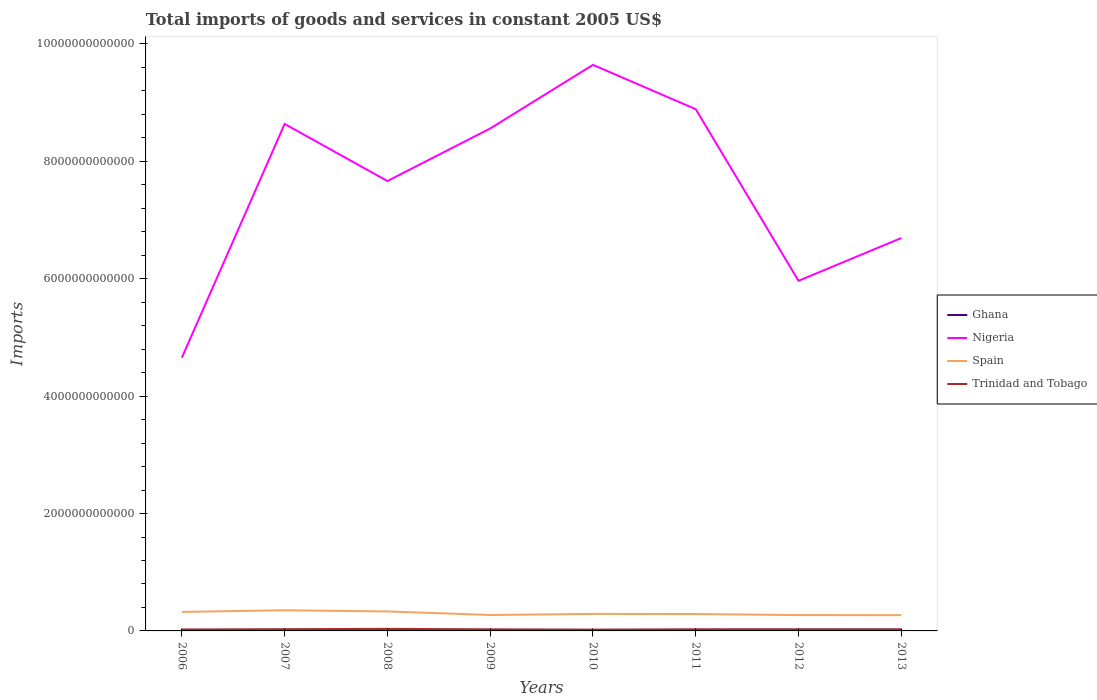How many different coloured lines are there?
Give a very brief answer. 4. Does the line corresponding to Spain intersect with the line corresponding to Ghana?
Keep it short and to the point. No. Is the number of lines equal to the number of legend labels?
Provide a succinct answer. Yes. Across all years, what is the maximum total imports of goods and services in Nigeria?
Give a very brief answer. 4.66e+12. What is the total total imports of goods and services in Spain in the graph?
Provide a short and direct response. -1.64e+1. What is the difference between the highest and the second highest total imports of goods and services in Spain?
Keep it short and to the point. 8.28e+1. What is the difference between the highest and the lowest total imports of goods and services in Trinidad and Tobago?
Offer a terse response. 2. Is the total imports of goods and services in Ghana strictly greater than the total imports of goods and services in Trinidad and Tobago over the years?
Make the answer very short. Yes. How many lines are there?
Ensure brevity in your answer.  4. How many years are there in the graph?
Provide a succinct answer. 8. What is the difference between two consecutive major ticks on the Y-axis?
Provide a short and direct response. 2.00e+12. How many legend labels are there?
Ensure brevity in your answer.  4. How are the legend labels stacked?
Keep it short and to the point. Vertical. What is the title of the graph?
Your answer should be compact. Total imports of goods and services in constant 2005 US$. What is the label or title of the X-axis?
Your answer should be very brief. Years. What is the label or title of the Y-axis?
Offer a very short reply. Imports. What is the Imports of Ghana in 2006?
Give a very brief answer. 7.62e+09. What is the Imports of Nigeria in 2006?
Keep it short and to the point. 4.66e+12. What is the Imports of Spain in 2006?
Provide a succinct answer. 3.24e+11. What is the Imports of Trinidad and Tobago in 2006?
Make the answer very short. 2.49e+1. What is the Imports in Ghana in 2007?
Make the answer very short. 9.27e+09. What is the Imports of Nigeria in 2007?
Provide a succinct answer. 8.64e+12. What is the Imports of Spain in 2007?
Provide a short and direct response. 3.52e+11. What is the Imports in Trinidad and Tobago in 2007?
Your answer should be compact. 2.99e+1. What is the Imports of Ghana in 2008?
Your answer should be very brief. 1.16e+1. What is the Imports of Nigeria in 2008?
Your response must be concise. 7.67e+12. What is the Imports of Spain in 2008?
Make the answer very short. 3.32e+11. What is the Imports in Trinidad and Tobago in 2008?
Provide a succinct answer. 3.48e+1. What is the Imports of Ghana in 2009?
Offer a terse response. 1.01e+1. What is the Imports in Nigeria in 2009?
Offer a terse response. 8.56e+12. What is the Imports in Spain in 2009?
Provide a succinct answer. 2.71e+11. What is the Imports of Trinidad and Tobago in 2009?
Offer a very short reply. 2.74e+1. What is the Imports of Ghana in 2010?
Provide a succinct answer. 1.28e+1. What is the Imports in Nigeria in 2010?
Keep it short and to the point. 9.64e+12. What is the Imports of Spain in 2010?
Your answer should be very brief. 2.90e+11. What is the Imports in Trinidad and Tobago in 2010?
Keep it short and to the point. 2.25e+1. What is the Imports in Ghana in 2011?
Keep it short and to the point. 1.79e+1. What is the Imports of Nigeria in 2011?
Offer a terse response. 8.89e+12. What is the Imports in Spain in 2011?
Your response must be concise. 2.88e+11. What is the Imports of Trinidad and Tobago in 2011?
Your answer should be compact. 2.76e+1. What is the Imports of Ghana in 2012?
Your answer should be very brief. 2.02e+1. What is the Imports in Nigeria in 2012?
Make the answer very short. 5.97e+12. What is the Imports of Spain in 2012?
Make the answer very short. 2.70e+11. What is the Imports of Trinidad and Tobago in 2012?
Provide a succinct answer. 2.70e+1. What is the Imports of Ghana in 2013?
Offer a very short reply. 2.07e+1. What is the Imports in Nigeria in 2013?
Your answer should be compact. 6.69e+12. What is the Imports of Spain in 2013?
Ensure brevity in your answer.  2.69e+11. What is the Imports of Trinidad and Tobago in 2013?
Offer a terse response. 2.68e+1. Across all years, what is the maximum Imports of Ghana?
Give a very brief answer. 2.07e+1. Across all years, what is the maximum Imports in Nigeria?
Offer a terse response. 9.64e+12. Across all years, what is the maximum Imports in Spain?
Your answer should be very brief. 3.52e+11. Across all years, what is the maximum Imports of Trinidad and Tobago?
Offer a terse response. 3.48e+1. Across all years, what is the minimum Imports of Ghana?
Provide a succinct answer. 7.62e+09. Across all years, what is the minimum Imports of Nigeria?
Provide a succinct answer. 4.66e+12. Across all years, what is the minimum Imports of Spain?
Offer a terse response. 2.69e+11. Across all years, what is the minimum Imports of Trinidad and Tobago?
Provide a short and direct response. 2.25e+1. What is the total Imports of Ghana in the graph?
Give a very brief answer. 1.10e+11. What is the total Imports in Nigeria in the graph?
Ensure brevity in your answer.  6.07e+13. What is the total Imports of Spain in the graph?
Provide a short and direct response. 2.40e+12. What is the total Imports in Trinidad and Tobago in the graph?
Your response must be concise. 2.21e+11. What is the difference between the Imports in Ghana in 2006 and that in 2007?
Your response must be concise. -1.65e+09. What is the difference between the Imports in Nigeria in 2006 and that in 2007?
Provide a succinct answer. -3.98e+12. What is the difference between the Imports of Spain in 2006 and that in 2007?
Your response must be concise. -2.77e+1. What is the difference between the Imports of Trinidad and Tobago in 2006 and that in 2007?
Your response must be concise. -5.04e+09. What is the difference between the Imports of Ghana in 2006 and that in 2008?
Your response must be concise. -3.94e+09. What is the difference between the Imports in Nigeria in 2006 and that in 2008?
Your answer should be very brief. -3.01e+12. What is the difference between the Imports in Spain in 2006 and that in 2008?
Offer a very short reply. -7.98e+09. What is the difference between the Imports of Trinidad and Tobago in 2006 and that in 2008?
Make the answer very short. -9.90e+09. What is the difference between the Imports of Ghana in 2006 and that in 2009?
Ensure brevity in your answer.  -2.49e+09. What is the difference between the Imports in Nigeria in 2006 and that in 2009?
Give a very brief answer. -3.90e+12. What is the difference between the Imports of Spain in 2006 and that in 2009?
Provide a succinct answer. 5.28e+1. What is the difference between the Imports in Trinidad and Tobago in 2006 and that in 2009?
Give a very brief answer. -2.50e+09. What is the difference between the Imports in Ghana in 2006 and that in 2010?
Your answer should be very brief. -5.18e+09. What is the difference between the Imports of Nigeria in 2006 and that in 2010?
Keep it short and to the point. -4.99e+12. What is the difference between the Imports of Spain in 2006 and that in 2010?
Your response must be concise. 3.40e+1. What is the difference between the Imports in Trinidad and Tobago in 2006 and that in 2010?
Provide a succinct answer. 2.35e+09. What is the difference between the Imports in Ghana in 2006 and that in 2011?
Offer a terse response. -1.03e+1. What is the difference between the Imports in Nigeria in 2006 and that in 2011?
Offer a terse response. -4.23e+12. What is the difference between the Imports of Spain in 2006 and that in 2011?
Ensure brevity in your answer.  3.64e+1. What is the difference between the Imports of Trinidad and Tobago in 2006 and that in 2011?
Your response must be concise. -2.72e+09. What is the difference between the Imports of Ghana in 2006 and that in 2012?
Your answer should be very brief. -1.26e+1. What is the difference between the Imports in Nigeria in 2006 and that in 2012?
Your answer should be very brief. -1.31e+12. What is the difference between the Imports in Spain in 2006 and that in 2012?
Provide a succinct answer. 5.42e+1. What is the difference between the Imports in Trinidad and Tobago in 2006 and that in 2012?
Your answer should be compact. -2.12e+09. What is the difference between the Imports of Ghana in 2006 and that in 2013?
Your response must be concise. -1.31e+1. What is the difference between the Imports of Nigeria in 2006 and that in 2013?
Provide a short and direct response. -2.04e+12. What is the difference between the Imports of Spain in 2006 and that in 2013?
Keep it short and to the point. 5.50e+1. What is the difference between the Imports of Trinidad and Tobago in 2006 and that in 2013?
Your answer should be compact. -1.94e+09. What is the difference between the Imports in Ghana in 2007 and that in 2008?
Your answer should be very brief. -2.28e+09. What is the difference between the Imports of Nigeria in 2007 and that in 2008?
Ensure brevity in your answer.  9.72e+11. What is the difference between the Imports in Spain in 2007 and that in 2008?
Make the answer very short. 1.98e+1. What is the difference between the Imports of Trinidad and Tobago in 2007 and that in 2008?
Offer a terse response. -4.86e+09. What is the difference between the Imports in Ghana in 2007 and that in 2009?
Ensure brevity in your answer.  -8.33e+08. What is the difference between the Imports of Nigeria in 2007 and that in 2009?
Your answer should be very brief. 7.73e+1. What is the difference between the Imports of Spain in 2007 and that in 2009?
Offer a very short reply. 8.06e+1. What is the difference between the Imports of Trinidad and Tobago in 2007 and that in 2009?
Provide a short and direct response. 2.54e+09. What is the difference between the Imports in Ghana in 2007 and that in 2010?
Your answer should be very brief. -3.53e+09. What is the difference between the Imports of Nigeria in 2007 and that in 2010?
Keep it short and to the point. -1.01e+12. What is the difference between the Imports of Spain in 2007 and that in 2010?
Provide a short and direct response. 6.18e+1. What is the difference between the Imports of Trinidad and Tobago in 2007 and that in 2010?
Make the answer very short. 7.40e+09. What is the difference between the Imports in Ghana in 2007 and that in 2011?
Your answer should be compact. -8.66e+09. What is the difference between the Imports of Nigeria in 2007 and that in 2011?
Make the answer very short. -2.51e+11. What is the difference between the Imports in Spain in 2007 and that in 2011?
Make the answer very short. 6.41e+1. What is the difference between the Imports of Trinidad and Tobago in 2007 and that in 2011?
Offer a very short reply. 2.32e+09. What is the difference between the Imports of Ghana in 2007 and that in 2012?
Ensure brevity in your answer.  -1.10e+1. What is the difference between the Imports of Nigeria in 2007 and that in 2012?
Your answer should be compact. 2.67e+12. What is the difference between the Imports of Spain in 2007 and that in 2012?
Offer a terse response. 8.19e+1. What is the difference between the Imports in Trinidad and Tobago in 2007 and that in 2012?
Provide a short and direct response. 2.93e+09. What is the difference between the Imports of Ghana in 2007 and that in 2013?
Make the answer very short. -1.14e+1. What is the difference between the Imports in Nigeria in 2007 and that in 2013?
Your answer should be very brief. 1.94e+12. What is the difference between the Imports of Spain in 2007 and that in 2013?
Keep it short and to the point. 8.28e+1. What is the difference between the Imports of Trinidad and Tobago in 2007 and that in 2013?
Your answer should be very brief. 3.10e+09. What is the difference between the Imports in Ghana in 2008 and that in 2009?
Your answer should be very brief. 1.45e+09. What is the difference between the Imports of Nigeria in 2008 and that in 2009?
Your answer should be very brief. -8.95e+11. What is the difference between the Imports of Spain in 2008 and that in 2009?
Your response must be concise. 6.08e+1. What is the difference between the Imports in Trinidad and Tobago in 2008 and that in 2009?
Ensure brevity in your answer.  7.40e+09. What is the difference between the Imports of Ghana in 2008 and that in 2010?
Keep it short and to the point. -1.25e+09. What is the difference between the Imports in Nigeria in 2008 and that in 2010?
Ensure brevity in your answer.  -1.98e+12. What is the difference between the Imports of Spain in 2008 and that in 2010?
Your response must be concise. 4.20e+1. What is the difference between the Imports of Trinidad and Tobago in 2008 and that in 2010?
Give a very brief answer. 1.23e+1. What is the difference between the Imports of Ghana in 2008 and that in 2011?
Provide a succinct answer. -6.38e+09. What is the difference between the Imports in Nigeria in 2008 and that in 2011?
Offer a terse response. -1.22e+12. What is the difference between the Imports of Spain in 2008 and that in 2011?
Your response must be concise. 4.44e+1. What is the difference between the Imports in Trinidad and Tobago in 2008 and that in 2011?
Your answer should be very brief. 7.18e+09. What is the difference between the Imports in Ghana in 2008 and that in 2012?
Offer a terse response. -8.67e+09. What is the difference between the Imports of Nigeria in 2008 and that in 2012?
Your answer should be compact. 1.70e+12. What is the difference between the Imports in Spain in 2008 and that in 2012?
Provide a succinct answer. 6.22e+1. What is the difference between the Imports of Trinidad and Tobago in 2008 and that in 2012?
Keep it short and to the point. 7.79e+09. What is the difference between the Imports in Ghana in 2008 and that in 2013?
Your answer should be very brief. -9.13e+09. What is the difference between the Imports in Nigeria in 2008 and that in 2013?
Keep it short and to the point. 9.71e+11. What is the difference between the Imports in Spain in 2008 and that in 2013?
Offer a very short reply. 6.30e+1. What is the difference between the Imports of Trinidad and Tobago in 2008 and that in 2013?
Give a very brief answer. 7.96e+09. What is the difference between the Imports of Ghana in 2009 and that in 2010?
Keep it short and to the point. -2.70e+09. What is the difference between the Imports in Nigeria in 2009 and that in 2010?
Offer a very short reply. -1.08e+12. What is the difference between the Imports of Spain in 2009 and that in 2010?
Provide a short and direct response. -1.88e+1. What is the difference between the Imports of Trinidad and Tobago in 2009 and that in 2010?
Provide a succinct answer. 4.85e+09. What is the difference between the Imports of Ghana in 2009 and that in 2011?
Ensure brevity in your answer.  -7.83e+09. What is the difference between the Imports in Nigeria in 2009 and that in 2011?
Provide a short and direct response. -3.29e+11. What is the difference between the Imports of Spain in 2009 and that in 2011?
Provide a succinct answer. -1.64e+1. What is the difference between the Imports of Trinidad and Tobago in 2009 and that in 2011?
Make the answer very short. -2.24e+08. What is the difference between the Imports of Ghana in 2009 and that in 2012?
Ensure brevity in your answer.  -1.01e+1. What is the difference between the Imports in Nigeria in 2009 and that in 2012?
Keep it short and to the point. 2.60e+12. What is the difference between the Imports of Spain in 2009 and that in 2012?
Your answer should be compact. 1.37e+09. What is the difference between the Imports of Trinidad and Tobago in 2009 and that in 2012?
Your answer should be compact. 3.81e+08. What is the difference between the Imports of Ghana in 2009 and that in 2013?
Provide a short and direct response. -1.06e+1. What is the difference between the Imports of Nigeria in 2009 and that in 2013?
Ensure brevity in your answer.  1.87e+12. What is the difference between the Imports of Spain in 2009 and that in 2013?
Your answer should be very brief. 2.22e+09. What is the difference between the Imports in Trinidad and Tobago in 2009 and that in 2013?
Your response must be concise. 5.55e+08. What is the difference between the Imports in Ghana in 2010 and that in 2011?
Give a very brief answer. -5.13e+09. What is the difference between the Imports in Nigeria in 2010 and that in 2011?
Give a very brief answer. 7.55e+11. What is the difference between the Imports of Spain in 2010 and that in 2011?
Offer a terse response. 2.33e+09. What is the difference between the Imports in Trinidad and Tobago in 2010 and that in 2011?
Ensure brevity in your answer.  -5.08e+09. What is the difference between the Imports in Ghana in 2010 and that in 2012?
Ensure brevity in your answer.  -7.42e+09. What is the difference between the Imports of Nigeria in 2010 and that in 2012?
Your answer should be very brief. 3.68e+12. What is the difference between the Imports of Spain in 2010 and that in 2012?
Keep it short and to the point. 2.01e+1. What is the difference between the Imports of Trinidad and Tobago in 2010 and that in 2012?
Make the answer very short. -4.47e+09. What is the difference between the Imports in Ghana in 2010 and that in 2013?
Make the answer very short. -7.88e+09. What is the difference between the Imports in Nigeria in 2010 and that in 2013?
Provide a short and direct response. 2.95e+12. What is the difference between the Imports in Spain in 2010 and that in 2013?
Offer a very short reply. 2.10e+1. What is the difference between the Imports of Trinidad and Tobago in 2010 and that in 2013?
Your response must be concise. -4.30e+09. What is the difference between the Imports of Ghana in 2011 and that in 2012?
Offer a very short reply. -2.29e+09. What is the difference between the Imports in Nigeria in 2011 and that in 2012?
Offer a very short reply. 2.92e+12. What is the difference between the Imports in Spain in 2011 and that in 2012?
Give a very brief answer. 1.78e+1. What is the difference between the Imports in Trinidad and Tobago in 2011 and that in 2012?
Offer a terse response. 6.05e+08. What is the difference between the Imports of Ghana in 2011 and that in 2013?
Offer a very short reply. -2.75e+09. What is the difference between the Imports of Nigeria in 2011 and that in 2013?
Provide a succinct answer. 2.20e+12. What is the difference between the Imports in Spain in 2011 and that in 2013?
Ensure brevity in your answer.  1.87e+1. What is the difference between the Imports of Trinidad and Tobago in 2011 and that in 2013?
Your response must be concise. 7.79e+08. What is the difference between the Imports in Ghana in 2012 and that in 2013?
Keep it short and to the point. -4.60e+08. What is the difference between the Imports of Nigeria in 2012 and that in 2013?
Your response must be concise. -7.29e+11. What is the difference between the Imports of Spain in 2012 and that in 2013?
Keep it short and to the point. 8.52e+08. What is the difference between the Imports of Trinidad and Tobago in 2012 and that in 2013?
Provide a short and direct response. 1.74e+08. What is the difference between the Imports of Ghana in 2006 and the Imports of Nigeria in 2007?
Give a very brief answer. -8.63e+12. What is the difference between the Imports in Ghana in 2006 and the Imports in Spain in 2007?
Your response must be concise. -3.44e+11. What is the difference between the Imports in Ghana in 2006 and the Imports in Trinidad and Tobago in 2007?
Provide a short and direct response. -2.23e+1. What is the difference between the Imports in Nigeria in 2006 and the Imports in Spain in 2007?
Provide a short and direct response. 4.30e+12. What is the difference between the Imports of Nigeria in 2006 and the Imports of Trinidad and Tobago in 2007?
Offer a very short reply. 4.63e+12. What is the difference between the Imports in Spain in 2006 and the Imports in Trinidad and Tobago in 2007?
Give a very brief answer. 2.94e+11. What is the difference between the Imports in Ghana in 2006 and the Imports in Nigeria in 2008?
Provide a succinct answer. -7.66e+12. What is the difference between the Imports in Ghana in 2006 and the Imports in Spain in 2008?
Make the answer very short. -3.24e+11. What is the difference between the Imports of Ghana in 2006 and the Imports of Trinidad and Tobago in 2008?
Provide a short and direct response. -2.72e+1. What is the difference between the Imports of Nigeria in 2006 and the Imports of Spain in 2008?
Ensure brevity in your answer.  4.32e+12. What is the difference between the Imports in Nigeria in 2006 and the Imports in Trinidad and Tobago in 2008?
Make the answer very short. 4.62e+12. What is the difference between the Imports of Spain in 2006 and the Imports of Trinidad and Tobago in 2008?
Your response must be concise. 2.89e+11. What is the difference between the Imports of Ghana in 2006 and the Imports of Nigeria in 2009?
Offer a terse response. -8.55e+12. What is the difference between the Imports in Ghana in 2006 and the Imports in Spain in 2009?
Offer a terse response. -2.64e+11. What is the difference between the Imports of Ghana in 2006 and the Imports of Trinidad and Tobago in 2009?
Make the answer very short. -1.98e+1. What is the difference between the Imports in Nigeria in 2006 and the Imports in Spain in 2009?
Provide a short and direct response. 4.38e+12. What is the difference between the Imports of Nigeria in 2006 and the Imports of Trinidad and Tobago in 2009?
Your response must be concise. 4.63e+12. What is the difference between the Imports of Spain in 2006 and the Imports of Trinidad and Tobago in 2009?
Your answer should be compact. 2.97e+11. What is the difference between the Imports in Ghana in 2006 and the Imports in Nigeria in 2010?
Provide a succinct answer. -9.64e+12. What is the difference between the Imports in Ghana in 2006 and the Imports in Spain in 2010?
Offer a terse response. -2.82e+11. What is the difference between the Imports of Ghana in 2006 and the Imports of Trinidad and Tobago in 2010?
Offer a very short reply. -1.49e+1. What is the difference between the Imports of Nigeria in 2006 and the Imports of Spain in 2010?
Ensure brevity in your answer.  4.37e+12. What is the difference between the Imports of Nigeria in 2006 and the Imports of Trinidad and Tobago in 2010?
Keep it short and to the point. 4.63e+12. What is the difference between the Imports of Spain in 2006 and the Imports of Trinidad and Tobago in 2010?
Your response must be concise. 3.01e+11. What is the difference between the Imports in Ghana in 2006 and the Imports in Nigeria in 2011?
Give a very brief answer. -8.88e+12. What is the difference between the Imports of Ghana in 2006 and the Imports of Spain in 2011?
Offer a terse response. -2.80e+11. What is the difference between the Imports of Ghana in 2006 and the Imports of Trinidad and Tobago in 2011?
Make the answer very short. -2.00e+1. What is the difference between the Imports of Nigeria in 2006 and the Imports of Spain in 2011?
Provide a succinct answer. 4.37e+12. What is the difference between the Imports in Nigeria in 2006 and the Imports in Trinidad and Tobago in 2011?
Your answer should be compact. 4.63e+12. What is the difference between the Imports of Spain in 2006 and the Imports of Trinidad and Tobago in 2011?
Ensure brevity in your answer.  2.96e+11. What is the difference between the Imports in Ghana in 2006 and the Imports in Nigeria in 2012?
Offer a very short reply. -5.96e+12. What is the difference between the Imports in Ghana in 2006 and the Imports in Spain in 2012?
Make the answer very short. -2.62e+11. What is the difference between the Imports of Ghana in 2006 and the Imports of Trinidad and Tobago in 2012?
Offer a terse response. -1.94e+1. What is the difference between the Imports of Nigeria in 2006 and the Imports of Spain in 2012?
Give a very brief answer. 4.39e+12. What is the difference between the Imports in Nigeria in 2006 and the Imports in Trinidad and Tobago in 2012?
Offer a very short reply. 4.63e+12. What is the difference between the Imports of Spain in 2006 and the Imports of Trinidad and Tobago in 2012?
Your answer should be compact. 2.97e+11. What is the difference between the Imports of Ghana in 2006 and the Imports of Nigeria in 2013?
Your answer should be compact. -6.69e+12. What is the difference between the Imports of Ghana in 2006 and the Imports of Spain in 2013?
Make the answer very short. -2.61e+11. What is the difference between the Imports of Ghana in 2006 and the Imports of Trinidad and Tobago in 2013?
Your answer should be very brief. -1.92e+1. What is the difference between the Imports of Nigeria in 2006 and the Imports of Spain in 2013?
Ensure brevity in your answer.  4.39e+12. What is the difference between the Imports in Nigeria in 2006 and the Imports in Trinidad and Tobago in 2013?
Provide a short and direct response. 4.63e+12. What is the difference between the Imports in Spain in 2006 and the Imports in Trinidad and Tobago in 2013?
Keep it short and to the point. 2.97e+11. What is the difference between the Imports of Ghana in 2007 and the Imports of Nigeria in 2008?
Your answer should be compact. -7.66e+12. What is the difference between the Imports of Ghana in 2007 and the Imports of Spain in 2008?
Give a very brief answer. -3.23e+11. What is the difference between the Imports in Ghana in 2007 and the Imports in Trinidad and Tobago in 2008?
Your answer should be compact. -2.55e+1. What is the difference between the Imports of Nigeria in 2007 and the Imports of Spain in 2008?
Provide a short and direct response. 8.31e+12. What is the difference between the Imports in Nigeria in 2007 and the Imports in Trinidad and Tobago in 2008?
Keep it short and to the point. 8.60e+12. What is the difference between the Imports of Spain in 2007 and the Imports of Trinidad and Tobago in 2008?
Provide a short and direct response. 3.17e+11. What is the difference between the Imports of Ghana in 2007 and the Imports of Nigeria in 2009?
Your answer should be very brief. -8.55e+12. What is the difference between the Imports in Ghana in 2007 and the Imports in Spain in 2009?
Your answer should be very brief. -2.62e+11. What is the difference between the Imports in Ghana in 2007 and the Imports in Trinidad and Tobago in 2009?
Keep it short and to the point. -1.81e+1. What is the difference between the Imports of Nigeria in 2007 and the Imports of Spain in 2009?
Ensure brevity in your answer.  8.37e+12. What is the difference between the Imports of Nigeria in 2007 and the Imports of Trinidad and Tobago in 2009?
Provide a succinct answer. 8.61e+12. What is the difference between the Imports of Spain in 2007 and the Imports of Trinidad and Tobago in 2009?
Your answer should be very brief. 3.24e+11. What is the difference between the Imports in Ghana in 2007 and the Imports in Nigeria in 2010?
Offer a very short reply. -9.64e+12. What is the difference between the Imports of Ghana in 2007 and the Imports of Spain in 2010?
Provide a succinct answer. -2.81e+11. What is the difference between the Imports of Ghana in 2007 and the Imports of Trinidad and Tobago in 2010?
Offer a terse response. -1.33e+1. What is the difference between the Imports in Nigeria in 2007 and the Imports in Spain in 2010?
Provide a short and direct response. 8.35e+12. What is the difference between the Imports in Nigeria in 2007 and the Imports in Trinidad and Tobago in 2010?
Ensure brevity in your answer.  8.62e+12. What is the difference between the Imports of Spain in 2007 and the Imports of Trinidad and Tobago in 2010?
Your response must be concise. 3.29e+11. What is the difference between the Imports of Ghana in 2007 and the Imports of Nigeria in 2011?
Offer a terse response. -8.88e+12. What is the difference between the Imports of Ghana in 2007 and the Imports of Spain in 2011?
Your answer should be very brief. -2.78e+11. What is the difference between the Imports in Ghana in 2007 and the Imports in Trinidad and Tobago in 2011?
Offer a terse response. -1.83e+1. What is the difference between the Imports in Nigeria in 2007 and the Imports in Spain in 2011?
Make the answer very short. 8.35e+12. What is the difference between the Imports in Nigeria in 2007 and the Imports in Trinidad and Tobago in 2011?
Give a very brief answer. 8.61e+12. What is the difference between the Imports in Spain in 2007 and the Imports in Trinidad and Tobago in 2011?
Make the answer very short. 3.24e+11. What is the difference between the Imports in Ghana in 2007 and the Imports in Nigeria in 2012?
Your answer should be very brief. -5.96e+12. What is the difference between the Imports of Ghana in 2007 and the Imports of Spain in 2012?
Ensure brevity in your answer.  -2.61e+11. What is the difference between the Imports in Ghana in 2007 and the Imports in Trinidad and Tobago in 2012?
Ensure brevity in your answer.  -1.77e+1. What is the difference between the Imports of Nigeria in 2007 and the Imports of Spain in 2012?
Provide a short and direct response. 8.37e+12. What is the difference between the Imports of Nigeria in 2007 and the Imports of Trinidad and Tobago in 2012?
Offer a very short reply. 8.61e+12. What is the difference between the Imports of Spain in 2007 and the Imports of Trinidad and Tobago in 2012?
Offer a very short reply. 3.25e+11. What is the difference between the Imports of Ghana in 2007 and the Imports of Nigeria in 2013?
Give a very brief answer. -6.68e+12. What is the difference between the Imports of Ghana in 2007 and the Imports of Spain in 2013?
Ensure brevity in your answer.  -2.60e+11. What is the difference between the Imports in Ghana in 2007 and the Imports in Trinidad and Tobago in 2013?
Ensure brevity in your answer.  -1.75e+1. What is the difference between the Imports in Nigeria in 2007 and the Imports in Spain in 2013?
Offer a very short reply. 8.37e+12. What is the difference between the Imports of Nigeria in 2007 and the Imports of Trinidad and Tobago in 2013?
Offer a terse response. 8.61e+12. What is the difference between the Imports of Spain in 2007 and the Imports of Trinidad and Tobago in 2013?
Provide a succinct answer. 3.25e+11. What is the difference between the Imports of Ghana in 2008 and the Imports of Nigeria in 2009?
Ensure brevity in your answer.  -8.55e+12. What is the difference between the Imports of Ghana in 2008 and the Imports of Spain in 2009?
Your answer should be very brief. -2.60e+11. What is the difference between the Imports in Ghana in 2008 and the Imports in Trinidad and Tobago in 2009?
Your answer should be very brief. -1.58e+1. What is the difference between the Imports of Nigeria in 2008 and the Imports of Spain in 2009?
Ensure brevity in your answer.  7.39e+12. What is the difference between the Imports in Nigeria in 2008 and the Imports in Trinidad and Tobago in 2009?
Make the answer very short. 7.64e+12. What is the difference between the Imports of Spain in 2008 and the Imports of Trinidad and Tobago in 2009?
Give a very brief answer. 3.05e+11. What is the difference between the Imports in Ghana in 2008 and the Imports in Nigeria in 2010?
Make the answer very short. -9.63e+12. What is the difference between the Imports in Ghana in 2008 and the Imports in Spain in 2010?
Make the answer very short. -2.78e+11. What is the difference between the Imports of Ghana in 2008 and the Imports of Trinidad and Tobago in 2010?
Your answer should be very brief. -1.10e+1. What is the difference between the Imports in Nigeria in 2008 and the Imports in Spain in 2010?
Keep it short and to the point. 7.38e+12. What is the difference between the Imports in Nigeria in 2008 and the Imports in Trinidad and Tobago in 2010?
Provide a short and direct response. 7.64e+12. What is the difference between the Imports of Spain in 2008 and the Imports of Trinidad and Tobago in 2010?
Offer a terse response. 3.09e+11. What is the difference between the Imports in Ghana in 2008 and the Imports in Nigeria in 2011?
Your answer should be compact. -8.88e+12. What is the difference between the Imports of Ghana in 2008 and the Imports of Spain in 2011?
Make the answer very short. -2.76e+11. What is the difference between the Imports of Ghana in 2008 and the Imports of Trinidad and Tobago in 2011?
Your answer should be compact. -1.60e+1. What is the difference between the Imports in Nigeria in 2008 and the Imports in Spain in 2011?
Provide a succinct answer. 7.38e+12. What is the difference between the Imports in Nigeria in 2008 and the Imports in Trinidad and Tobago in 2011?
Keep it short and to the point. 7.64e+12. What is the difference between the Imports of Spain in 2008 and the Imports of Trinidad and Tobago in 2011?
Make the answer very short. 3.04e+11. What is the difference between the Imports in Ghana in 2008 and the Imports in Nigeria in 2012?
Provide a succinct answer. -5.95e+12. What is the difference between the Imports of Ghana in 2008 and the Imports of Spain in 2012?
Keep it short and to the point. -2.58e+11. What is the difference between the Imports in Ghana in 2008 and the Imports in Trinidad and Tobago in 2012?
Keep it short and to the point. -1.54e+1. What is the difference between the Imports in Nigeria in 2008 and the Imports in Spain in 2012?
Your answer should be very brief. 7.40e+12. What is the difference between the Imports of Nigeria in 2008 and the Imports of Trinidad and Tobago in 2012?
Your answer should be very brief. 7.64e+12. What is the difference between the Imports of Spain in 2008 and the Imports of Trinidad and Tobago in 2012?
Your answer should be very brief. 3.05e+11. What is the difference between the Imports of Ghana in 2008 and the Imports of Nigeria in 2013?
Offer a terse response. -6.68e+12. What is the difference between the Imports of Ghana in 2008 and the Imports of Spain in 2013?
Give a very brief answer. -2.57e+11. What is the difference between the Imports of Ghana in 2008 and the Imports of Trinidad and Tobago in 2013?
Offer a terse response. -1.53e+1. What is the difference between the Imports of Nigeria in 2008 and the Imports of Spain in 2013?
Keep it short and to the point. 7.40e+12. What is the difference between the Imports in Nigeria in 2008 and the Imports in Trinidad and Tobago in 2013?
Your response must be concise. 7.64e+12. What is the difference between the Imports of Spain in 2008 and the Imports of Trinidad and Tobago in 2013?
Provide a succinct answer. 3.05e+11. What is the difference between the Imports in Ghana in 2009 and the Imports in Nigeria in 2010?
Give a very brief answer. -9.63e+12. What is the difference between the Imports of Ghana in 2009 and the Imports of Spain in 2010?
Keep it short and to the point. -2.80e+11. What is the difference between the Imports of Ghana in 2009 and the Imports of Trinidad and Tobago in 2010?
Provide a short and direct response. -1.24e+1. What is the difference between the Imports of Nigeria in 2009 and the Imports of Spain in 2010?
Give a very brief answer. 8.27e+12. What is the difference between the Imports of Nigeria in 2009 and the Imports of Trinidad and Tobago in 2010?
Your response must be concise. 8.54e+12. What is the difference between the Imports in Spain in 2009 and the Imports in Trinidad and Tobago in 2010?
Offer a very short reply. 2.49e+11. What is the difference between the Imports in Ghana in 2009 and the Imports in Nigeria in 2011?
Give a very brief answer. -8.88e+12. What is the difference between the Imports of Ghana in 2009 and the Imports of Spain in 2011?
Make the answer very short. -2.78e+11. What is the difference between the Imports of Ghana in 2009 and the Imports of Trinidad and Tobago in 2011?
Provide a short and direct response. -1.75e+1. What is the difference between the Imports in Nigeria in 2009 and the Imports in Spain in 2011?
Your response must be concise. 8.27e+12. What is the difference between the Imports of Nigeria in 2009 and the Imports of Trinidad and Tobago in 2011?
Your response must be concise. 8.53e+12. What is the difference between the Imports of Spain in 2009 and the Imports of Trinidad and Tobago in 2011?
Give a very brief answer. 2.44e+11. What is the difference between the Imports of Ghana in 2009 and the Imports of Nigeria in 2012?
Offer a very short reply. -5.96e+12. What is the difference between the Imports in Ghana in 2009 and the Imports in Spain in 2012?
Offer a terse response. -2.60e+11. What is the difference between the Imports in Ghana in 2009 and the Imports in Trinidad and Tobago in 2012?
Give a very brief answer. -1.69e+1. What is the difference between the Imports in Nigeria in 2009 and the Imports in Spain in 2012?
Ensure brevity in your answer.  8.29e+12. What is the difference between the Imports in Nigeria in 2009 and the Imports in Trinidad and Tobago in 2012?
Your answer should be very brief. 8.53e+12. What is the difference between the Imports in Spain in 2009 and the Imports in Trinidad and Tobago in 2012?
Make the answer very short. 2.44e+11. What is the difference between the Imports in Ghana in 2009 and the Imports in Nigeria in 2013?
Your answer should be compact. -6.68e+12. What is the difference between the Imports in Ghana in 2009 and the Imports in Spain in 2013?
Provide a succinct answer. -2.59e+11. What is the difference between the Imports of Ghana in 2009 and the Imports of Trinidad and Tobago in 2013?
Provide a succinct answer. -1.67e+1. What is the difference between the Imports of Nigeria in 2009 and the Imports of Spain in 2013?
Give a very brief answer. 8.29e+12. What is the difference between the Imports of Nigeria in 2009 and the Imports of Trinidad and Tobago in 2013?
Offer a very short reply. 8.53e+12. What is the difference between the Imports in Spain in 2009 and the Imports in Trinidad and Tobago in 2013?
Your response must be concise. 2.44e+11. What is the difference between the Imports of Ghana in 2010 and the Imports of Nigeria in 2011?
Offer a very short reply. -8.88e+12. What is the difference between the Imports in Ghana in 2010 and the Imports in Spain in 2011?
Provide a succinct answer. -2.75e+11. What is the difference between the Imports of Ghana in 2010 and the Imports of Trinidad and Tobago in 2011?
Give a very brief answer. -1.48e+1. What is the difference between the Imports of Nigeria in 2010 and the Imports of Spain in 2011?
Offer a terse response. 9.36e+12. What is the difference between the Imports of Nigeria in 2010 and the Imports of Trinidad and Tobago in 2011?
Keep it short and to the point. 9.62e+12. What is the difference between the Imports in Spain in 2010 and the Imports in Trinidad and Tobago in 2011?
Provide a succinct answer. 2.62e+11. What is the difference between the Imports in Ghana in 2010 and the Imports in Nigeria in 2012?
Offer a terse response. -5.95e+12. What is the difference between the Imports of Ghana in 2010 and the Imports of Spain in 2012?
Your answer should be very brief. -2.57e+11. What is the difference between the Imports of Ghana in 2010 and the Imports of Trinidad and Tobago in 2012?
Provide a succinct answer. -1.42e+1. What is the difference between the Imports of Nigeria in 2010 and the Imports of Spain in 2012?
Ensure brevity in your answer.  9.37e+12. What is the difference between the Imports of Nigeria in 2010 and the Imports of Trinidad and Tobago in 2012?
Provide a succinct answer. 9.62e+12. What is the difference between the Imports in Spain in 2010 and the Imports in Trinidad and Tobago in 2012?
Offer a terse response. 2.63e+11. What is the difference between the Imports of Ghana in 2010 and the Imports of Nigeria in 2013?
Make the answer very short. -6.68e+12. What is the difference between the Imports in Ghana in 2010 and the Imports in Spain in 2013?
Your answer should be compact. -2.56e+11. What is the difference between the Imports in Ghana in 2010 and the Imports in Trinidad and Tobago in 2013?
Make the answer very short. -1.40e+1. What is the difference between the Imports in Nigeria in 2010 and the Imports in Spain in 2013?
Your answer should be very brief. 9.38e+12. What is the difference between the Imports in Nigeria in 2010 and the Imports in Trinidad and Tobago in 2013?
Ensure brevity in your answer.  9.62e+12. What is the difference between the Imports in Spain in 2010 and the Imports in Trinidad and Tobago in 2013?
Provide a succinct answer. 2.63e+11. What is the difference between the Imports of Ghana in 2011 and the Imports of Nigeria in 2012?
Make the answer very short. -5.95e+12. What is the difference between the Imports in Ghana in 2011 and the Imports in Spain in 2012?
Keep it short and to the point. -2.52e+11. What is the difference between the Imports of Ghana in 2011 and the Imports of Trinidad and Tobago in 2012?
Keep it short and to the point. -9.06e+09. What is the difference between the Imports in Nigeria in 2011 and the Imports in Spain in 2012?
Provide a short and direct response. 8.62e+12. What is the difference between the Imports of Nigeria in 2011 and the Imports of Trinidad and Tobago in 2012?
Provide a short and direct response. 8.86e+12. What is the difference between the Imports in Spain in 2011 and the Imports in Trinidad and Tobago in 2012?
Ensure brevity in your answer.  2.61e+11. What is the difference between the Imports in Ghana in 2011 and the Imports in Nigeria in 2013?
Ensure brevity in your answer.  -6.68e+12. What is the difference between the Imports of Ghana in 2011 and the Imports of Spain in 2013?
Keep it short and to the point. -2.51e+11. What is the difference between the Imports of Ghana in 2011 and the Imports of Trinidad and Tobago in 2013?
Your answer should be very brief. -8.89e+09. What is the difference between the Imports in Nigeria in 2011 and the Imports in Spain in 2013?
Your response must be concise. 8.62e+12. What is the difference between the Imports of Nigeria in 2011 and the Imports of Trinidad and Tobago in 2013?
Make the answer very short. 8.86e+12. What is the difference between the Imports in Spain in 2011 and the Imports in Trinidad and Tobago in 2013?
Provide a succinct answer. 2.61e+11. What is the difference between the Imports of Ghana in 2012 and the Imports of Nigeria in 2013?
Provide a succinct answer. -6.67e+12. What is the difference between the Imports of Ghana in 2012 and the Imports of Spain in 2013?
Provide a succinct answer. -2.49e+11. What is the difference between the Imports of Ghana in 2012 and the Imports of Trinidad and Tobago in 2013?
Keep it short and to the point. -6.59e+09. What is the difference between the Imports in Nigeria in 2012 and the Imports in Spain in 2013?
Offer a terse response. 5.70e+12. What is the difference between the Imports in Nigeria in 2012 and the Imports in Trinidad and Tobago in 2013?
Make the answer very short. 5.94e+12. What is the difference between the Imports in Spain in 2012 and the Imports in Trinidad and Tobago in 2013?
Give a very brief answer. 2.43e+11. What is the average Imports of Ghana per year?
Give a very brief answer. 1.38e+1. What is the average Imports of Nigeria per year?
Give a very brief answer. 7.59e+12. What is the average Imports in Spain per year?
Keep it short and to the point. 2.99e+11. What is the average Imports of Trinidad and Tobago per year?
Keep it short and to the point. 2.76e+1. In the year 2006, what is the difference between the Imports in Ghana and Imports in Nigeria?
Provide a succinct answer. -4.65e+12. In the year 2006, what is the difference between the Imports in Ghana and Imports in Spain?
Provide a succinct answer. -3.16e+11. In the year 2006, what is the difference between the Imports of Ghana and Imports of Trinidad and Tobago?
Give a very brief answer. -1.73e+1. In the year 2006, what is the difference between the Imports in Nigeria and Imports in Spain?
Offer a terse response. 4.33e+12. In the year 2006, what is the difference between the Imports in Nigeria and Imports in Trinidad and Tobago?
Give a very brief answer. 4.63e+12. In the year 2006, what is the difference between the Imports of Spain and Imports of Trinidad and Tobago?
Give a very brief answer. 2.99e+11. In the year 2007, what is the difference between the Imports of Ghana and Imports of Nigeria?
Your response must be concise. -8.63e+12. In the year 2007, what is the difference between the Imports in Ghana and Imports in Spain?
Offer a terse response. -3.42e+11. In the year 2007, what is the difference between the Imports of Ghana and Imports of Trinidad and Tobago?
Ensure brevity in your answer.  -2.06e+1. In the year 2007, what is the difference between the Imports in Nigeria and Imports in Spain?
Offer a very short reply. 8.29e+12. In the year 2007, what is the difference between the Imports of Nigeria and Imports of Trinidad and Tobago?
Provide a short and direct response. 8.61e+12. In the year 2007, what is the difference between the Imports of Spain and Imports of Trinidad and Tobago?
Give a very brief answer. 3.22e+11. In the year 2008, what is the difference between the Imports of Ghana and Imports of Nigeria?
Your answer should be very brief. -7.65e+12. In the year 2008, what is the difference between the Imports of Ghana and Imports of Spain?
Provide a short and direct response. -3.20e+11. In the year 2008, what is the difference between the Imports in Ghana and Imports in Trinidad and Tobago?
Provide a short and direct response. -2.32e+1. In the year 2008, what is the difference between the Imports in Nigeria and Imports in Spain?
Give a very brief answer. 7.33e+12. In the year 2008, what is the difference between the Imports in Nigeria and Imports in Trinidad and Tobago?
Ensure brevity in your answer.  7.63e+12. In the year 2008, what is the difference between the Imports in Spain and Imports in Trinidad and Tobago?
Ensure brevity in your answer.  2.97e+11. In the year 2009, what is the difference between the Imports in Ghana and Imports in Nigeria?
Give a very brief answer. -8.55e+12. In the year 2009, what is the difference between the Imports in Ghana and Imports in Spain?
Provide a succinct answer. -2.61e+11. In the year 2009, what is the difference between the Imports of Ghana and Imports of Trinidad and Tobago?
Make the answer very short. -1.73e+1. In the year 2009, what is the difference between the Imports in Nigeria and Imports in Spain?
Provide a succinct answer. 8.29e+12. In the year 2009, what is the difference between the Imports in Nigeria and Imports in Trinidad and Tobago?
Your response must be concise. 8.53e+12. In the year 2009, what is the difference between the Imports of Spain and Imports of Trinidad and Tobago?
Keep it short and to the point. 2.44e+11. In the year 2010, what is the difference between the Imports in Ghana and Imports in Nigeria?
Give a very brief answer. -9.63e+12. In the year 2010, what is the difference between the Imports of Ghana and Imports of Spain?
Ensure brevity in your answer.  -2.77e+11. In the year 2010, what is the difference between the Imports in Ghana and Imports in Trinidad and Tobago?
Make the answer very short. -9.72e+09. In the year 2010, what is the difference between the Imports in Nigeria and Imports in Spain?
Your answer should be very brief. 9.35e+12. In the year 2010, what is the difference between the Imports in Nigeria and Imports in Trinidad and Tobago?
Provide a succinct answer. 9.62e+12. In the year 2010, what is the difference between the Imports in Spain and Imports in Trinidad and Tobago?
Give a very brief answer. 2.67e+11. In the year 2011, what is the difference between the Imports of Ghana and Imports of Nigeria?
Offer a very short reply. -8.87e+12. In the year 2011, what is the difference between the Imports of Ghana and Imports of Spain?
Your answer should be compact. -2.70e+11. In the year 2011, what is the difference between the Imports in Ghana and Imports in Trinidad and Tobago?
Offer a terse response. -9.67e+09. In the year 2011, what is the difference between the Imports of Nigeria and Imports of Spain?
Your answer should be compact. 8.60e+12. In the year 2011, what is the difference between the Imports in Nigeria and Imports in Trinidad and Tobago?
Offer a terse response. 8.86e+12. In the year 2011, what is the difference between the Imports in Spain and Imports in Trinidad and Tobago?
Ensure brevity in your answer.  2.60e+11. In the year 2012, what is the difference between the Imports in Ghana and Imports in Nigeria?
Offer a very short reply. -5.95e+12. In the year 2012, what is the difference between the Imports of Ghana and Imports of Spain?
Make the answer very short. -2.50e+11. In the year 2012, what is the difference between the Imports in Ghana and Imports in Trinidad and Tobago?
Ensure brevity in your answer.  -6.77e+09. In the year 2012, what is the difference between the Imports of Nigeria and Imports of Spain?
Provide a short and direct response. 5.70e+12. In the year 2012, what is the difference between the Imports in Nigeria and Imports in Trinidad and Tobago?
Provide a succinct answer. 5.94e+12. In the year 2012, what is the difference between the Imports of Spain and Imports of Trinidad and Tobago?
Give a very brief answer. 2.43e+11. In the year 2013, what is the difference between the Imports of Ghana and Imports of Nigeria?
Make the answer very short. -6.67e+12. In the year 2013, what is the difference between the Imports of Ghana and Imports of Spain?
Provide a short and direct response. -2.48e+11. In the year 2013, what is the difference between the Imports of Ghana and Imports of Trinidad and Tobago?
Provide a short and direct response. -6.13e+09. In the year 2013, what is the difference between the Imports in Nigeria and Imports in Spain?
Offer a terse response. 6.43e+12. In the year 2013, what is the difference between the Imports of Nigeria and Imports of Trinidad and Tobago?
Your answer should be very brief. 6.67e+12. In the year 2013, what is the difference between the Imports in Spain and Imports in Trinidad and Tobago?
Provide a short and direct response. 2.42e+11. What is the ratio of the Imports of Ghana in 2006 to that in 2007?
Keep it short and to the point. 0.82. What is the ratio of the Imports of Nigeria in 2006 to that in 2007?
Ensure brevity in your answer.  0.54. What is the ratio of the Imports in Spain in 2006 to that in 2007?
Your answer should be very brief. 0.92. What is the ratio of the Imports in Trinidad and Tobago in 2006 to that in 2007?
Your response must be concise. 0.83. What is the ratio of the Imports of Ghana in 2006 to that in 2008?
Your answer should be compact. 0.66. What is the ratio of the Imports in Nigeria in 2006 to that in 2008?
Provide a succinct answer. 0.61. What is the ratio of the Imports of Trinidad and Tobago in 2006 to that in 2008?
Offer a terse response. 0.72. What is the ratio of the Imports of Ghana in 2006 to that in 2009?
Give a very brief answer. 0.75. What is the ratio of the Imports of Nigeria in 2006 to that in 2009?
Your answer should be very brief. 0.54. What is the ratio of the Imports of Spain in 2006 to that in 2009?
Provide a short and direct response. 1.19. What is the ratio of the Imports of Trinidad and Tobago in 2006 to that in 2009?
Give a very brief answer. 0.91. What is the ratio of the Imports of Ghana in 2006 to that in 2010?
Your response must be concise. 0.6. What is the ratio of the Imports of Nigeria in 2006 to that in 2010?
Your answer should be very brief. 0.48. What is the ratio of the Imports of Spain in 2006 to that in 2010?
Your answer should be compact. 1.12. What is the ratio of the Imports of Trinidad and Tobago in 2006 to that in 2010?
Make the answer very short. 1.1. What is the ratio of the Imports of Ghana in 2006 to that in 2011?
Offer a terse response. 0.42. What is the ratio of the Imports in Nigeria in 2006 to that in 2011?
Offer a very short reply. 0.52. What is the ratio of the Imports of Spain in 2006 to that in 2011?
Your answer should be compact. 1.13. What is the ratio of the Imports of Trinidad and Tobago in 2006 to that in 2011?
Give a very brief answer. 0.9. What is the ratio of the Imports of Ghana in 2006 to that in 2012?
Offer a terse response. 0.38. What is the ratio of the Imports of Nigeria in 2006 to that in 2012?
Your answer should be very brief. 0.78. What is the ratio of the Imports in Spain in 2006 to that in 2012?
Provide a succinct answer. 1.2. What is the ratio of the Imports of Trinidad and Tobago in 2006 to that in 2012?
Provide a short and direct response. 0.92. What is the ratio of the Imports of Ghana in 2006 to that in 2013?
Make the answer very short. 0.37. What is the ratio of the Imports of Nigeria in 2006 to that in 2013?
Offer a very short reply. 0.7. What is the ratio of the Imports of Spain in 2006 to that in 2013?
Your response must be concise. 1.2. What is the ratio of the Imports of Trinidad and Tobago in 2006 to that in 2013?
Ensure brevity in your answer.  0.93. What is the ratio of the Imports of Ghana in 2007 to that in 2008?
Offer a very short reply. 0.8. What is the ratio of the Imports of Nigeria in 2007 to that in 2008?
Offer a very short reply. 1.13. What is the ratio of the Imports in Spain in 2007 to that in 2008?
Your answer should be very brief. 1.06. What is the ratio of the Imports of Trinidad and Tobago in 2007 to that in 2008?
Ensure brevity in your answer.  0.86. What is the ratio of the Imports in Ghana in 2007 to that in 2009?
Your answer should be very brief. 0.92. What is the ratio of the Imports in Spain in 2007 to that in 2009?
Provide a succinct answer. 1.3. What is the ratio of the Imports of Trinidad and Tobago in 2007 to that in 2009?
Your response must be concise. 1.09. What is the ratio of the Imports of Ghana in 2007 to that in 2010?
Keep it short and to the point. 0.72. What is the ratio of the Imports of Nigeria in 2007 to that in 2010?
Offer a terse response. 0.9. What is the ratio of the Imports of Spain in 2007 to that in 2010?
Offer a terse response. 1.21. What is the ratio of the Imports in Trinidad and Tobago in 2007 to that in 2010?
Your answer should be compact. 1.33. What is the ratio of the Imports in Ghana in 2007 to that in 2011?
Make the answer very short. 0.52. What is the ratio of the Imports of Nigeria in 2007 to that in 2011?
Offer a very short reply. 0.97. What is the ratio of the Imports in Spain in 2007 to that in 2011?
Provide a succinct answer. 1.22. What is the ratio of the Imports in Trinidad and Tobago in 2007 to that in 2011?
Keep it short and to the point. 1.08. What is the ratio of the Imports in Ghana in 2007 to that in 2012?
Provide a short and direct response. 0.46. What is the ratio of the Imports of Nigeria in 2007 to that in 2012?
Offer a very short reply. 1.45. What is the ratio of the Imports in Spain in 2007 to that in 2012?
Give a very brief answer. 1.3. What is the ratio of the Imports in Trinidad and Tobago in 2007 to that in 2012?
Offer a terse response. 1.11. What is the ratio of the Imports in Ghana in 2007 to that in 2013?
Offer a very short reply. 0.45. What is the ratio of the Imports in Nigeria in 2007 to that in 2013?
Provide a short and direct response. 1.29. What is the ratio of the Imports in Spain in 2007 to that in 2013?
Your answer should be compact. 1.31. What is the ratio of the Imports of Trinidad and Tobago in 2007 to that in 2013?
Offer a terse response. 1.12. What is the ratio of the Imports of Ghana in 2008 to that in 2009?
Keep it short and to the point. 1.14. What is the ratio of the Imports in Nigeria in 2008 to that in 2009?
Your answer should be very brief. 0.9. What is the ratio of the Imports in Spain in 2008 to that in 2009?
Your answer should be compact. 1.22. What is the ratio of the Imports in Trinidad and Tobago in 2008 to that in 2009?
Keep it short and to the point. 1.27. What is the ratio of the Imports in Ghana in 2008 to that in 2010?
Ensure brevity in your answer.  0.9. What is the ratio of the Imports in Nigeria in 2008 to that in 2010?
Give a very brief answer. 0.79. What is the ratio of the Imports of Spain in 2008 to that in 2010?
Offer a terse response. 1.15. What is the ratio of the Imports in Trinidad and Tobago in 2008 to that in 2010?
Keep it short and to the point. 1.54. What is the ratio of the Imports in Ghana in 2008 to that in 2011?
Give a very brief answer. 0.64. What is the ratio of the Imports of Nigeria in 2008 to that in 2011?
Ensure brevity in your answer.  0.86. What is the ratio of the Imports of Spain in 2008 to that in 2011?
Ensure brevity in your answer.  1.15. What is the ratio of the Imports in Trinidad and Tobago in 2008 to that in 2011?
Ensure brevity in your answer.  1.26. What is the ratio of the Imports in Ghana in 2008 to that in 2012?
Your answer should be compact. 0.57. What is the ratio of the Imports in Nigeria in 2008 to that in 2012?
Make the answer very short. 1.28. What is the ratio of the Imports of Spain in 2008 to that in 2012?
Keep it short and to the point. 1.23. What is the ratio of the Imports of Trinidad and Tobago in 2008 to that in 2012?
Provide a succinct answer. 1.29. What is the ratio of the Imports of Ghana in 2008 to that in 2013?
Your answer should be very brief. 0.56. What is the ratio of the Imports in Nigeria in 2008 to that in 2013?
Offer a terse response. 1.15. What is the ratio of the Imports in Spain in 2008 to that in 2013?
Your answer should be compact. 1.23. What is the ratio of the Imports of Trinidad and Tobago in 2008 to that in 2013?
Your answer should be very brief. 1.3. What is the ratio of the Imports of Ghana in 2009 to that in 2010?
Your answer should be very brief. 0.79. What is the ratio of the Imports of Nigeria in 2009 to that in 2010?
Ensure brevity in your answer.  0.89. What is the ratio of the Imports in Spain in 2009 to that in 2010?
Your answer should be very brief. 0.94. What is the ratio of the Imports of Trinidad and Tobago in 2009 to that in 2010?
Offer a very short reply. 1.22. What is the ratio of the Imports of Ghana in 2009 to that in 2011?
Your response must be concise. 0.56. What is the ratio of the Imports in Nigeria in 2009 to that in 2011?
Give a very brief answer. 0.96. What is the ratio of the Imports of Spain in 2009 to that in 2011?
Give a very brief answer. 0.94. What is the ratio of the Imports of Trinidad and Tobago in 2009 to that in 2011?
Offer a very short reply. 0.99. What is the ratio of the Imports of Ghana in 2009 to that in 2012?
Your response must be concise. 0.5. What is the ratio of the Imports in Nigeria in 2009 to that in 2012?
Provide a succinct answer. 1.44. What is the ratio of the Imports of Spain in 2009 to that in 2012?
Provide a succinct answer. 1.01. What is the ratio of the Imports of Trinidad and Tobago in 2009 to that in 2012?
Offer a terse response. 1.01. What is the ratio of the Imports in Ghana in 2009 to that in 2013?
Your answer should be very brief. 0.49. What is the ratio of the Imports of Nigeria in 2009 to that in 2013?
Make the answer very short. 1.28. What is the ratio of the Imports in Spain in 2009 to that in 2013?
Your answer should be compact. 1.01. What is the ratio of the Imports in Trinidad and Tobago in 2009 to that in 2013?
Provide a short and direct response. 1.02. What is the ratio of the Imports in Ghana in 2010 to that in 2011?
Make the answer very short. 0.71. What is the ratio of the Imports of Nigeria in 2010 to that in 2011?
Your response must be concise. 1.08. What is the ratio of the Imports of Trinidad and Tobago in 2010 to that in 2011?
Provide a succinct answer. 0.82. What is the ratio of the Imports of Ghana in 2010 to that in 2012?
Offer a very short reply. 0.63. What is the ratio of the Imports in Nigeria in 2010 to that in 2012?
Give a very brief answer. 1.62. What is the ratio of the Imports of Spain in 2010 to that in 2012?
Your answer should be compact. 1.07. What is the ratio of the Imports in Trinidad and Tobago in 2010 to that in 2012?
Offer a very short reply. 0.83. What is the ratio of the Imports in Ghana in 2010 to that in 2013?
Ensure brevity in your answer.  0.62. What is the ratio of the Imports of Nigeria in 2010 to that in 2013?
Your response must be concise. 1.44. What is the ratio of the Imports of Spain in 2010 to that in 2013?
Ensure brevity in your answer.  1.08. What is the ratio of the Imports of Trinidad and Tobago in 2010 to that in 2013?
Provide a succinct answer. 0.84. What is the ratio of the Imports in Ghana in 2011 to that in 2012?
Make the answer very short. 0.89. What is the ratio of the Imports in Nigeria in 2011 to that in 2012?
Provide a succinct answer. 1.49. What is the ratio of the Imports in Spain in 2011 to that in 2012?
Ensure brevity in your answer.  1.07. What is the ratio of the Imports of Trinidad and Tobago in 2011 to that in 2012?
Provide a succinct answer. 1.02. What is the ratio of the Imports of Ghana in 2011 to that in 2013?
Your response must be concise. 0.87. What is the ratio of the Imports in Nigeria in 2011 to that in 2013?
Give a very brief answer. 1.33. What is the ratio of the Imports of Spain in 2011 to that in 2013?
Offer a very short reply. 1.07. What is the ratio of the Imports of Trinidad and Tobago in 2011 to that in 2013?
Provide a short and direct response. 1.03. What is the ratio of the Imports of Ghana in 2012 to that in 2013?
Provide a succinct answer. 0.98. What is the ratio of the Imports of Nigeria in 2012 to that in 2013?
Ensure brevity in your answer.  0.89. What is the difference between the highest and the second highest Imports of Ghana?
Your response must be concise. 4.60e+08. What is the difference between the highest and the second highest Imports of Nigeria?
Keep it short and to the point. 7.55e+11. What is the difference between the highest and the second highest Imports in Spain?
Offer a terse response. 1.98e+1. What is the difference between the highest and the second highest Imports in Trinidad and Tobago?
Your response must be concise. 4.86e+09. What is the difference between the highest and the lowest Imports in Ghana?
Ensure brevity in your answer.  1.31e+1. What is the difference between the highest and the lowest Imports of Nigeria?
Give a very brief answer. 4.99e+12. What is the difference between the highest and the lowest Imports of Spain?
Offer a terse response. 8.28e+1. What is the difference between the highest and the lowest Imports in Trinidad and Tobago?
Your answer should be very brief. 1.23e+1. 